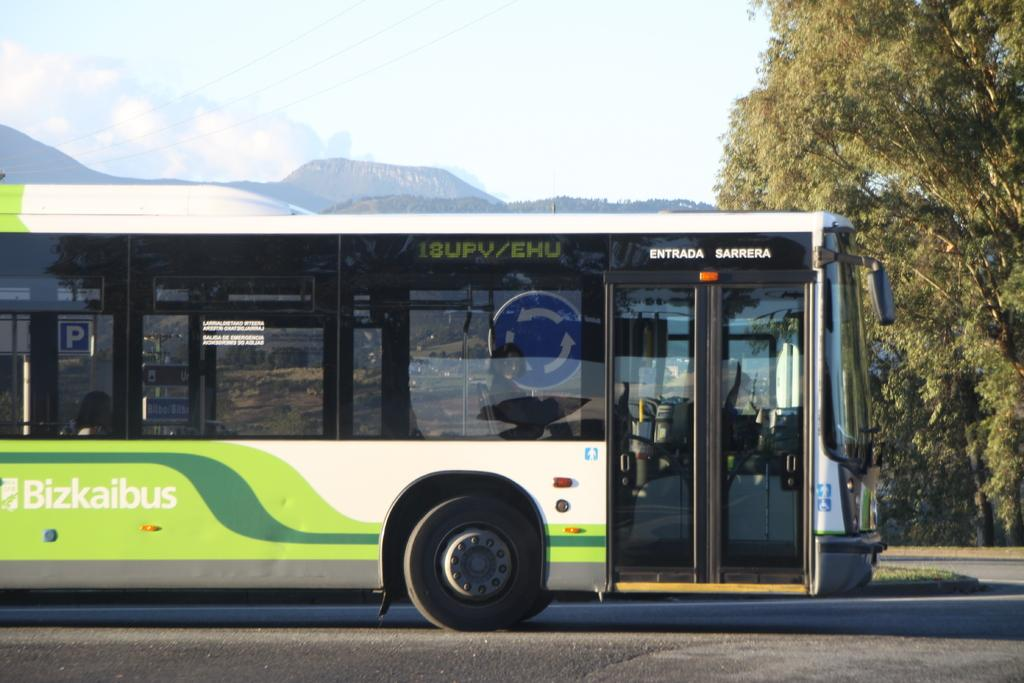<image>
Present a compact description of the photo's key features. A green and white bus that says bizkaibus on the side. 